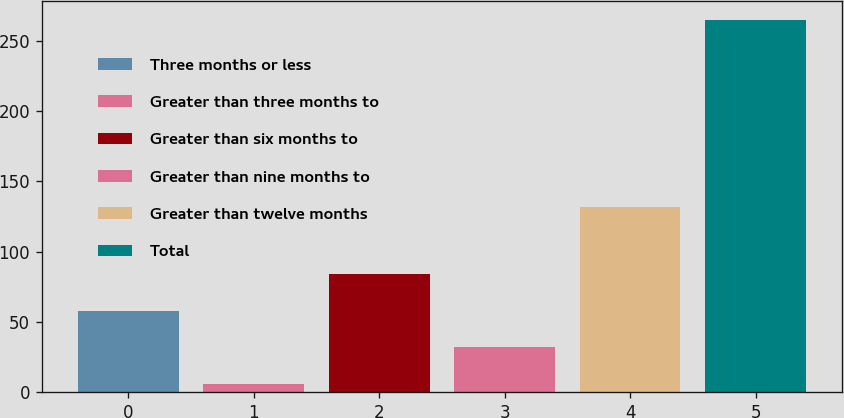Convert chart to OTSL. <chart><loc_0><loc_0><loc_500><loc_500><bar_chart><fcel>Three months or less<fcel>Greater than three months to<fcel>Greater than six months to<fcel>Greater than nine months to<fcel>Greater than twelve months<fcel>Total<nl><fcel>57.8<fcel>6<fcel>83.7<fcel>31.9<fcel>132<fcel>265<nl></chart> 